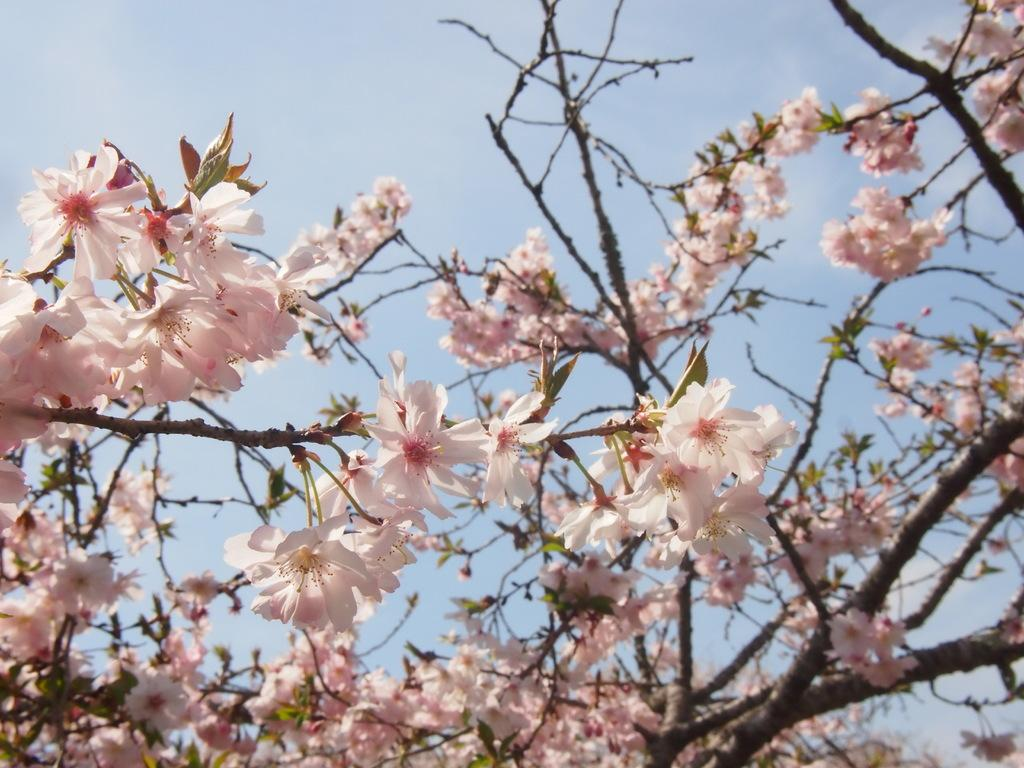What is located in the middle of the image? There are trees and flowers in the middle of the image. What can be seen behind the trees and flowers? The sky is visible behind the trees and flowers. What type of corn can be seen growing among the trees in the image? There is no corn visible in the image; it features trees and flowers. What grade is the tree in the image? The concept of a tree having a grade is not applicable, as trees are living organisms and not subject to grading systems. 